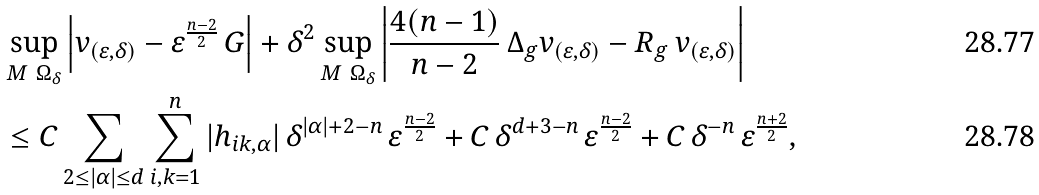Convert formula to latex. <formula><loc_0><loc_0><loc_500><loc_500>& \sup _ { M \ \Omega _ { \delta } } \left | v _ { ( \varepsilon , \delta ) } - \varepsilon ^ { \frac { n - 2 } { 2 } } \, G \right | + \delta ^ { 2 } \sup _ { M \ \Omega _ { \delta } } \left | \frac { 4 ( n - 1 ) } { n - 2 } \, \Delta _ { g } v _ { ( \varepsilon , \delta ) } - R _ { g } \, v _ { ( \varepsilon , \delta ) } \right | \\ & \leq C \sum _ { 2 \leq | \alpha | \leq d } \sum _ { i , k = 1 } ^ { n } | h _ { i k , \alpha } | \, \delta ^ { | \alpha | + 2 - n } \, \varepsilon ^ { \frac { n - 2 } { 2 } } + C \, \delta ^ { d + 3 - n } \, \varepsilon ^ { \frac { n - 2 } { 2 } } + C \, \delta ^ { - n } \, \varepsilon ^ { \frac { n + 2 } { 2 } } ,</formula> 